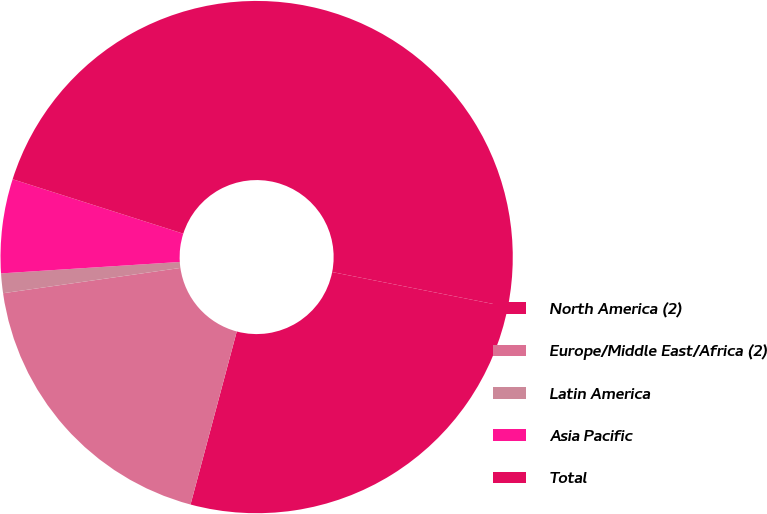<chart> <loc_0><loc_0><loc_500><loc_500><pie_chart><fcel>North America (2)<fcel>Europe/Middle East/Africa (2)<fcel>Latin America<fcel>Asia Pacific<fcel>Total<nl><fcel>26.04%<fcel>18.59%<fcel>1.24%<fcel>5.93%<fcel>48.2%<nl></chart> 